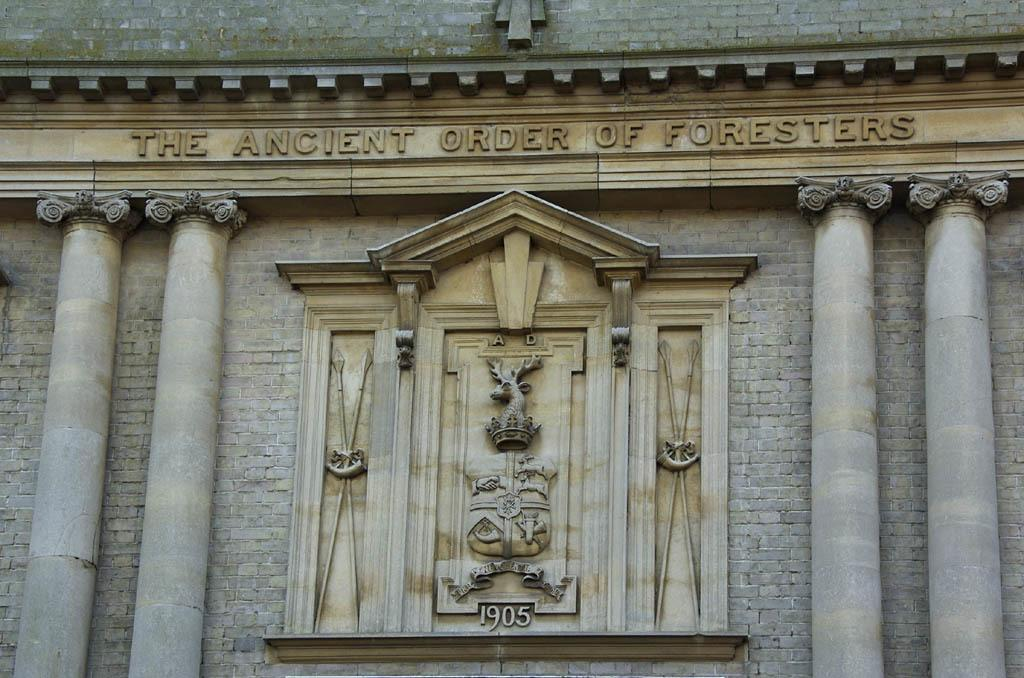What type of building is depicted in the image? There is a structure in the image that resembles a palace. What decorative elements can be seen on the palace walls? There are sculptures on the wall of the structure. Is there any text visible on the palace walls? Yes, there is text visible on the wall. How many spiders are crawling on the sculptures in the image? There are no spiders visible in the image; the focus is on the sculptures and text on the palace walls. 